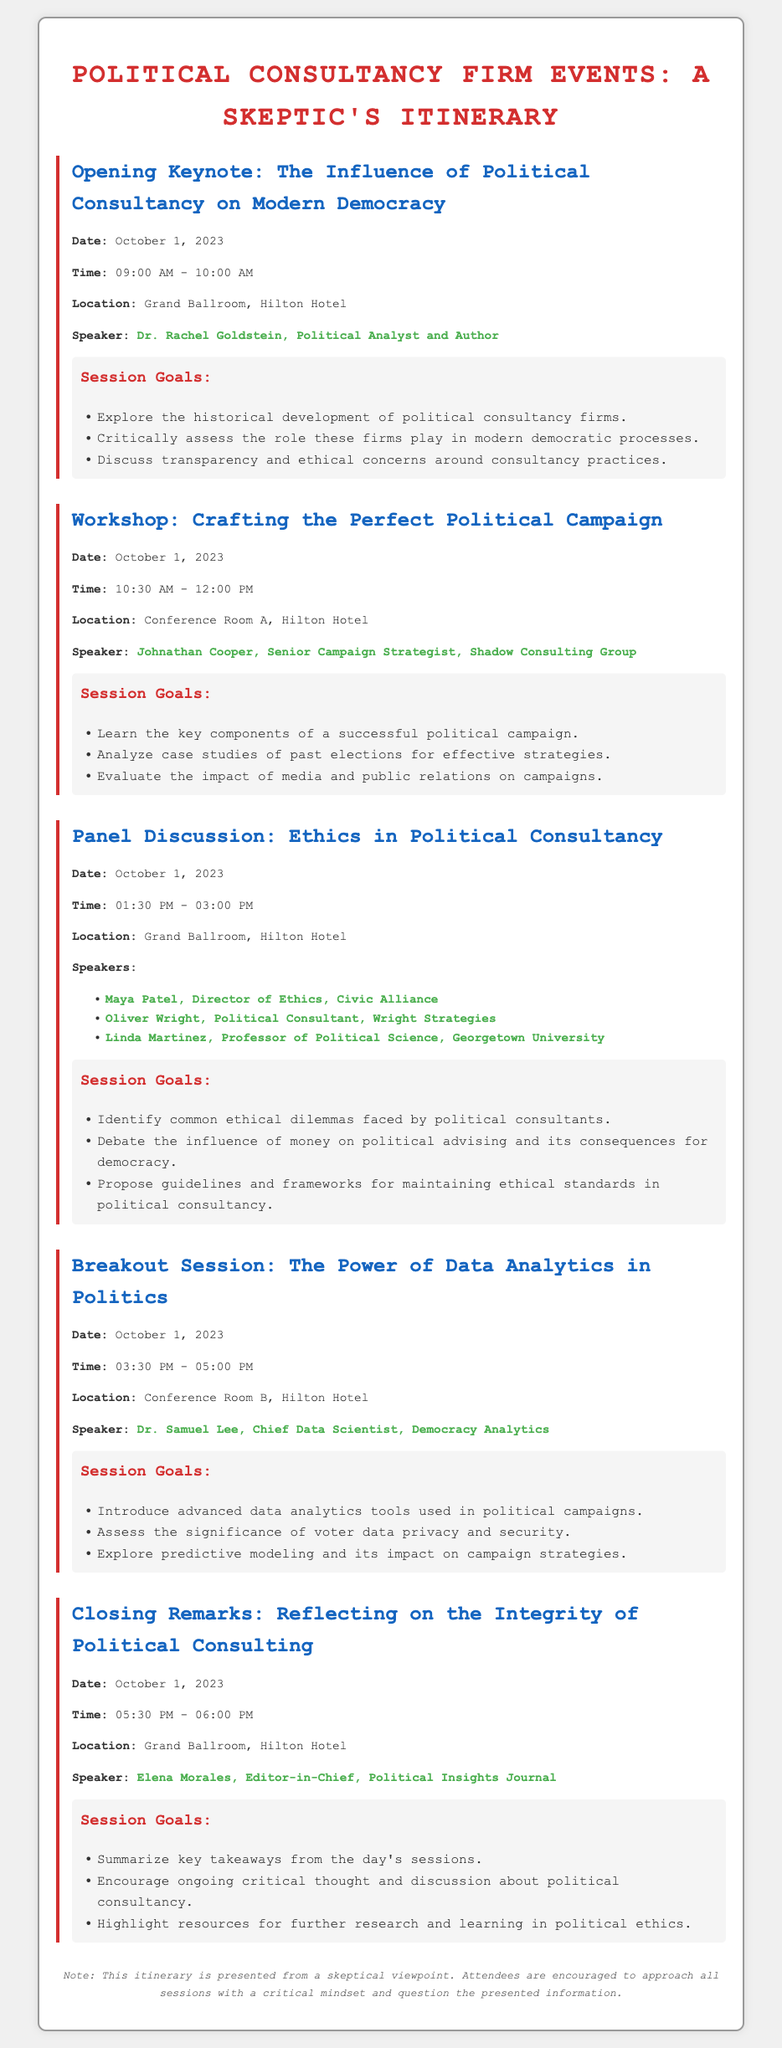what is the date of the Opening Keynote? The date of the Opening Keynote is listed in the event details section of the document.
Answer: October 1, 2023 who is the speaker for the Panel Discussion? The speakers are listed under the event details for the Panel Discussion section, allowing for identification of their names.
Answer: Maya Patel, Oliver Wright, Linda Martinez what time does the Breakout Session start? The start time is specified in the event details of the Breakout Session section of the document.
Answer: 03:30 PM how many speakers are listed for the Workshop? The number of speakers is determined by counting the provided details in the event section for the Workshop.
Answer: 1 what is a goal of the Closing Remarks session? The session goals are specifically outlined in the goals section of the Closing Remarks event, highlighting its objectives.
Answer: Summarize key takeaways from the day's sessions which room hosts the Crafting the Perfect Political Campaign workshop? The location of the workshop is specified under the event details section, providing clarity on where it will be held.
Answer: Conference Room A what type of session is the "Ethics in Political Consultancy"? The type of event is indicated by the title of the section, which is structured to describe the nature of the session.
Answer: Panel Discussion who is the last speaker of the day? Identification of the last speaker can be made by reviewing the details in the event for the Closing Remarks.
Answer: Elena Morales 